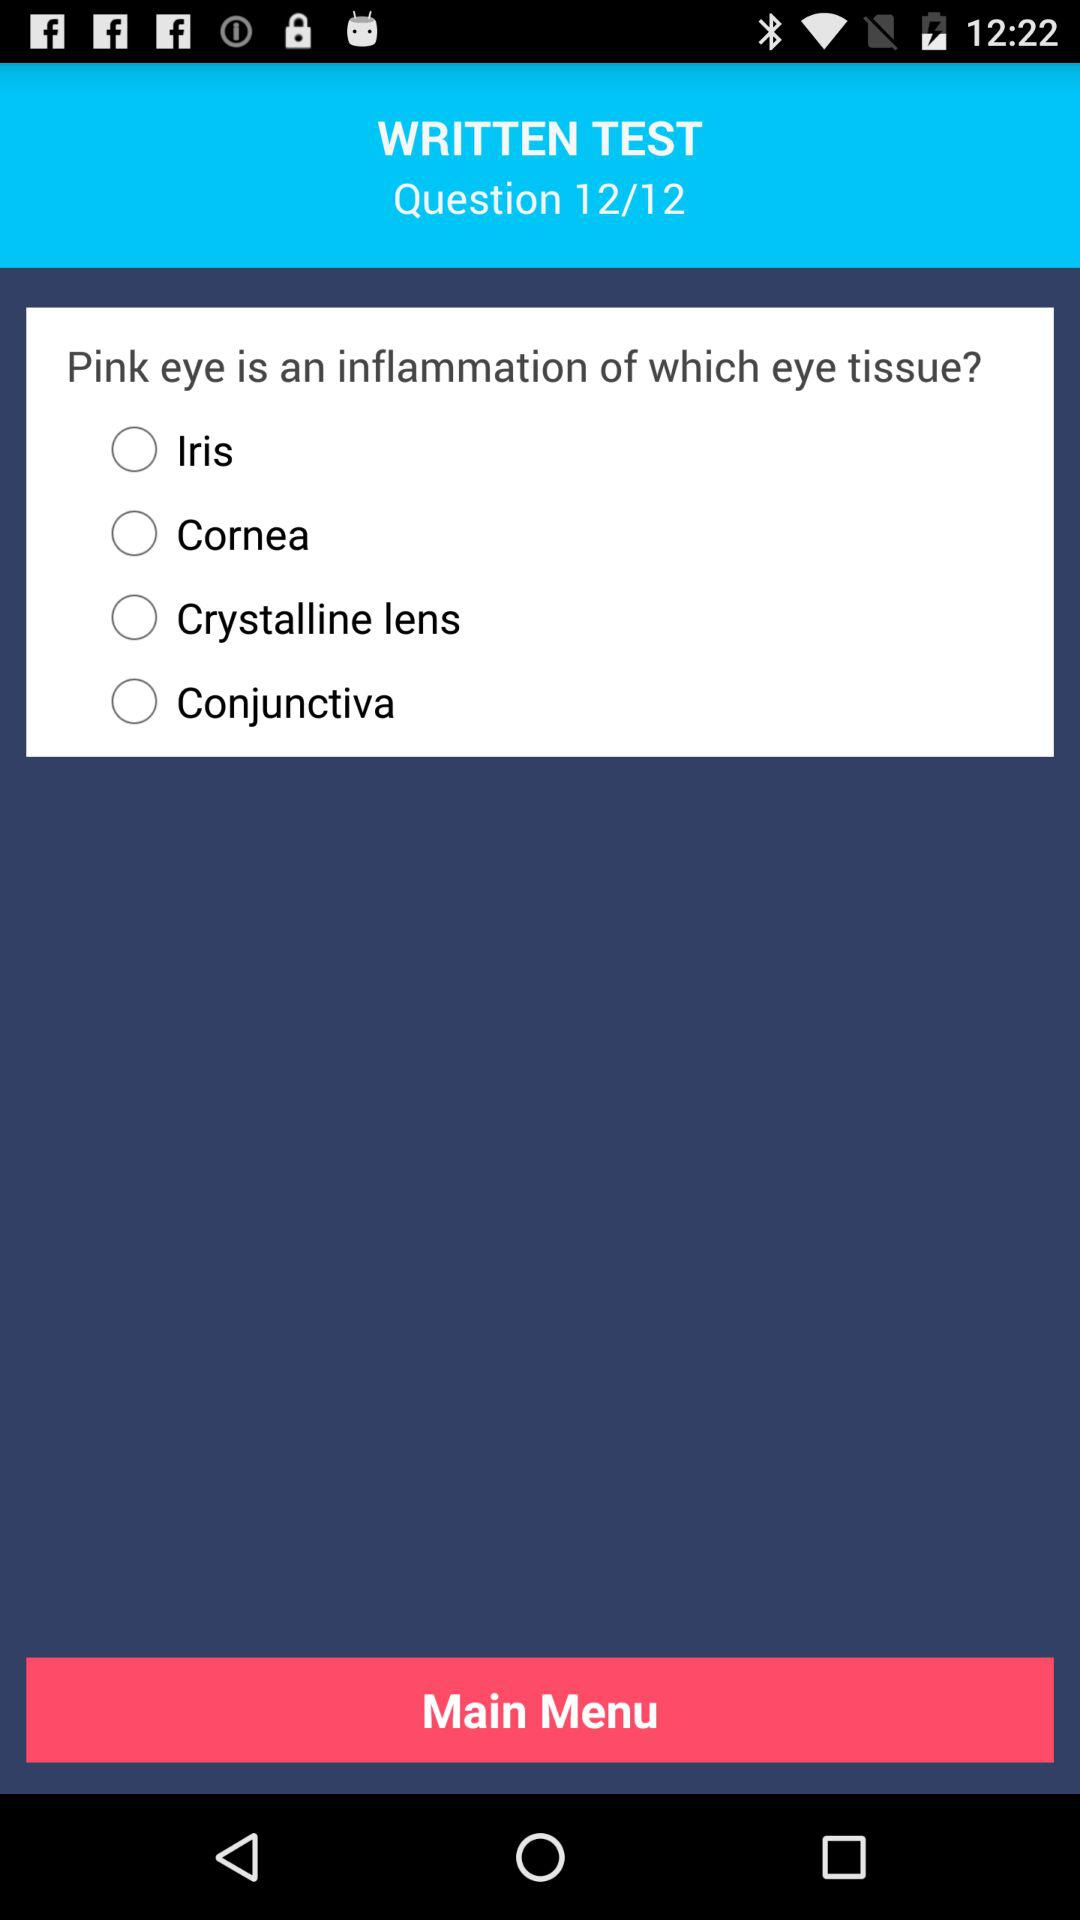Out of 12, at which question are we? Out of 12, you are at the twelfth question. 